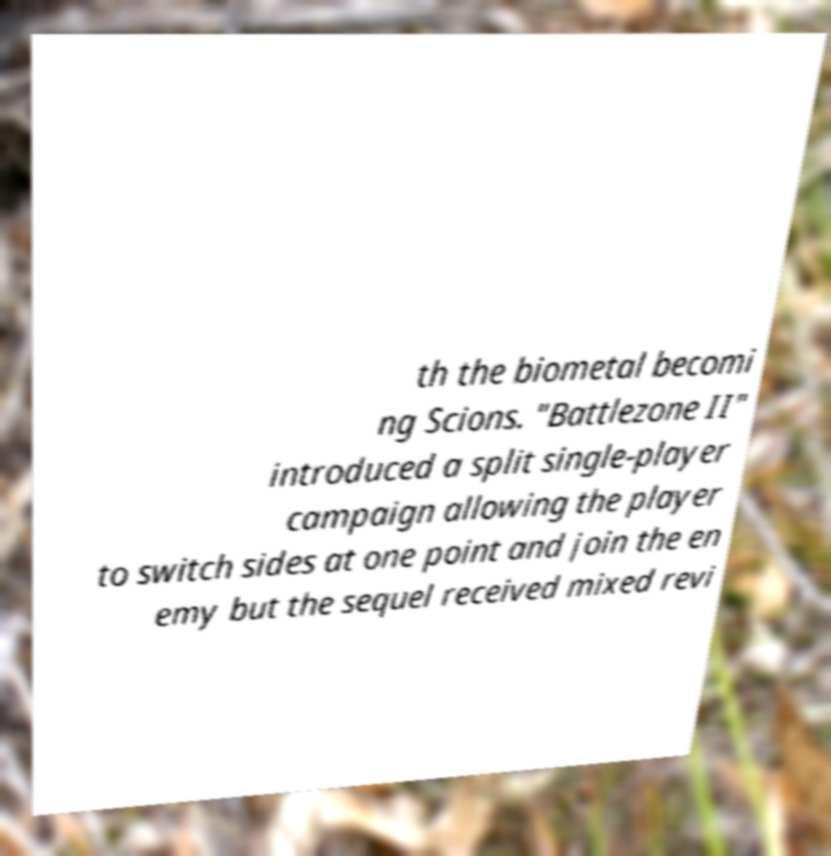I need the written content from this picture converted into text. Can you do that? th the biometal becomi ng Scions. "Battlezone II" introduced a split single-player campaign allowing the player to switch sides at one point and join the en emy but the sequel received mixed revi 